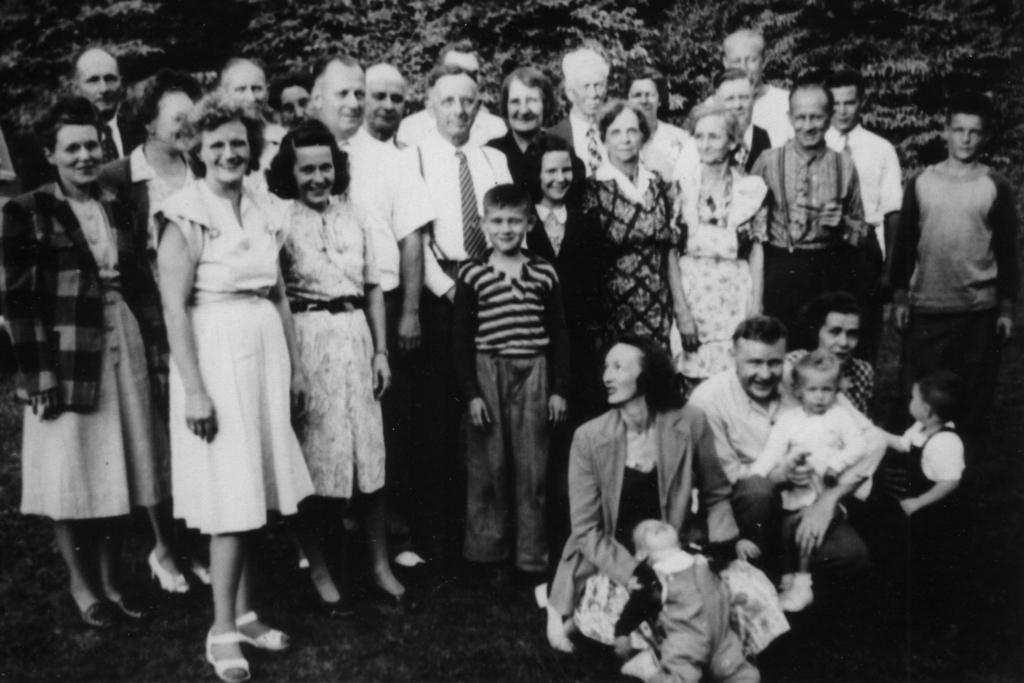Could you give a brief overview of what you see in this image? In this picture we can see the group of persons who is standing. In the bottom right we can see another group who are sitting on the floor. In the bank we can see the trees. On the left there is a woman who is wearing jacket and shoe. On the right there is a man who is wearing t-shirt and jeans. 